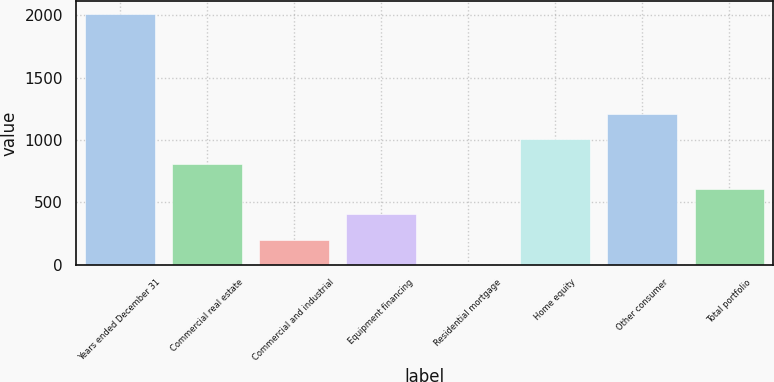Convert chart. <chart><loc_0><loc_0><loc_500><loc_500><bar_chart><fcel>Years ended December 31<fcel>Commercial real estate<fcel>Commercial and industrial<fcel>Equipment financing<fcel>Residential mortgage<fcel>Home equity<fcel>Other consumer<fcel>Total portfolio<nl><fcel>2012<fcel>804.89<fcel>201.35<fcel>402.53<fcel>0.17<fcel>1006.07<fcel>1207.25<fcel>603.71<nl></chart> 